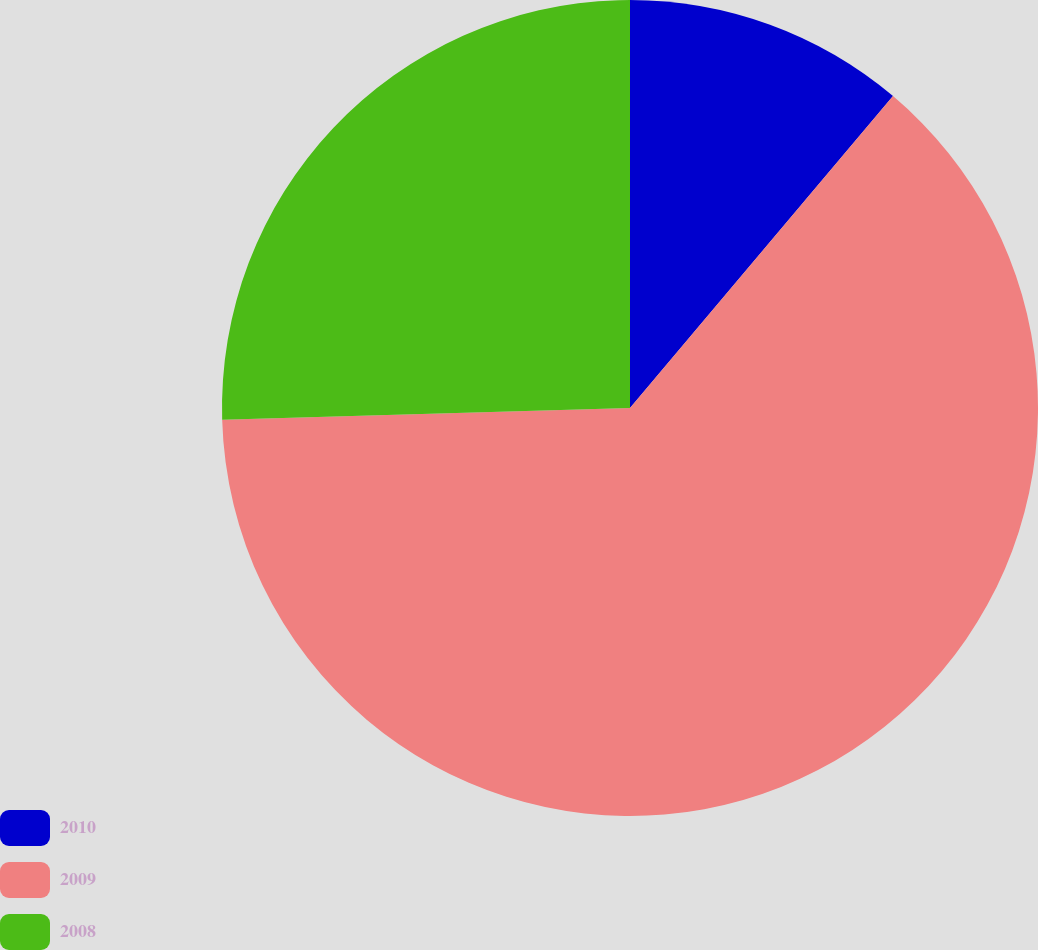Convert chart. <chart><loc_0><loc_0><loc_500><loc_500><pie_chart><fcel>2010<fcel>2009<fcel>2008<nl><fcel>11.15%<fcel>63.39%<fcel>25.46%<nl></chart> 